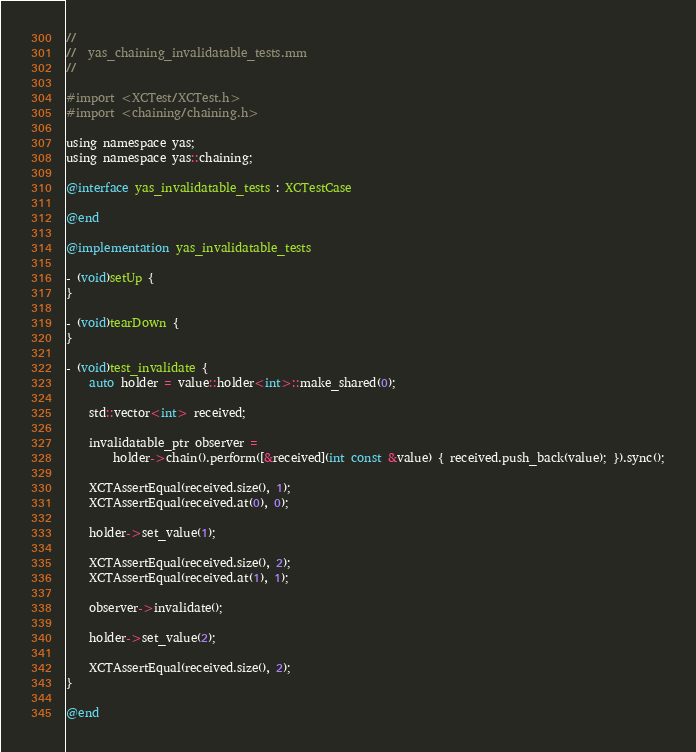<code> <loc_0><loc_0><loc_500><loc_500><_ObjectiveC_>//
//  yas_chaining_invalidatable_tests.mm
//

#import <XCTest/XCTest.h>
#import <chaining/chaining.h>

using namespace yas;
using namespace yas::chaining;

@interface yas_invalidatable_tests : XCTestCase

@end

@implementation yas_invalidatable_tests

- (void)setUp {
}

- (void)tearDown {
}

- (void)test_invalidate {
    auto holder = value::holder<int>::make_shared(0);

    std::vector<int> received;

    invalidatable_ptr observer =
        holder->chain().perform([&received](int const &value) { received.push_back(value); }).sync();

    XCTAssertEqual(received.size(), 1);
    XCTAssertEqual(received.at(0), 0);

    holder->set_value(1);

    XCTAssertEqual(received.size(), 2);
    XCTAssertEqual(received.at(1), 1);

    observer->invalidate();

    holder->set_value(2);

    XCTAssertEqual(received.size(), 2);
}

@end
</code> 